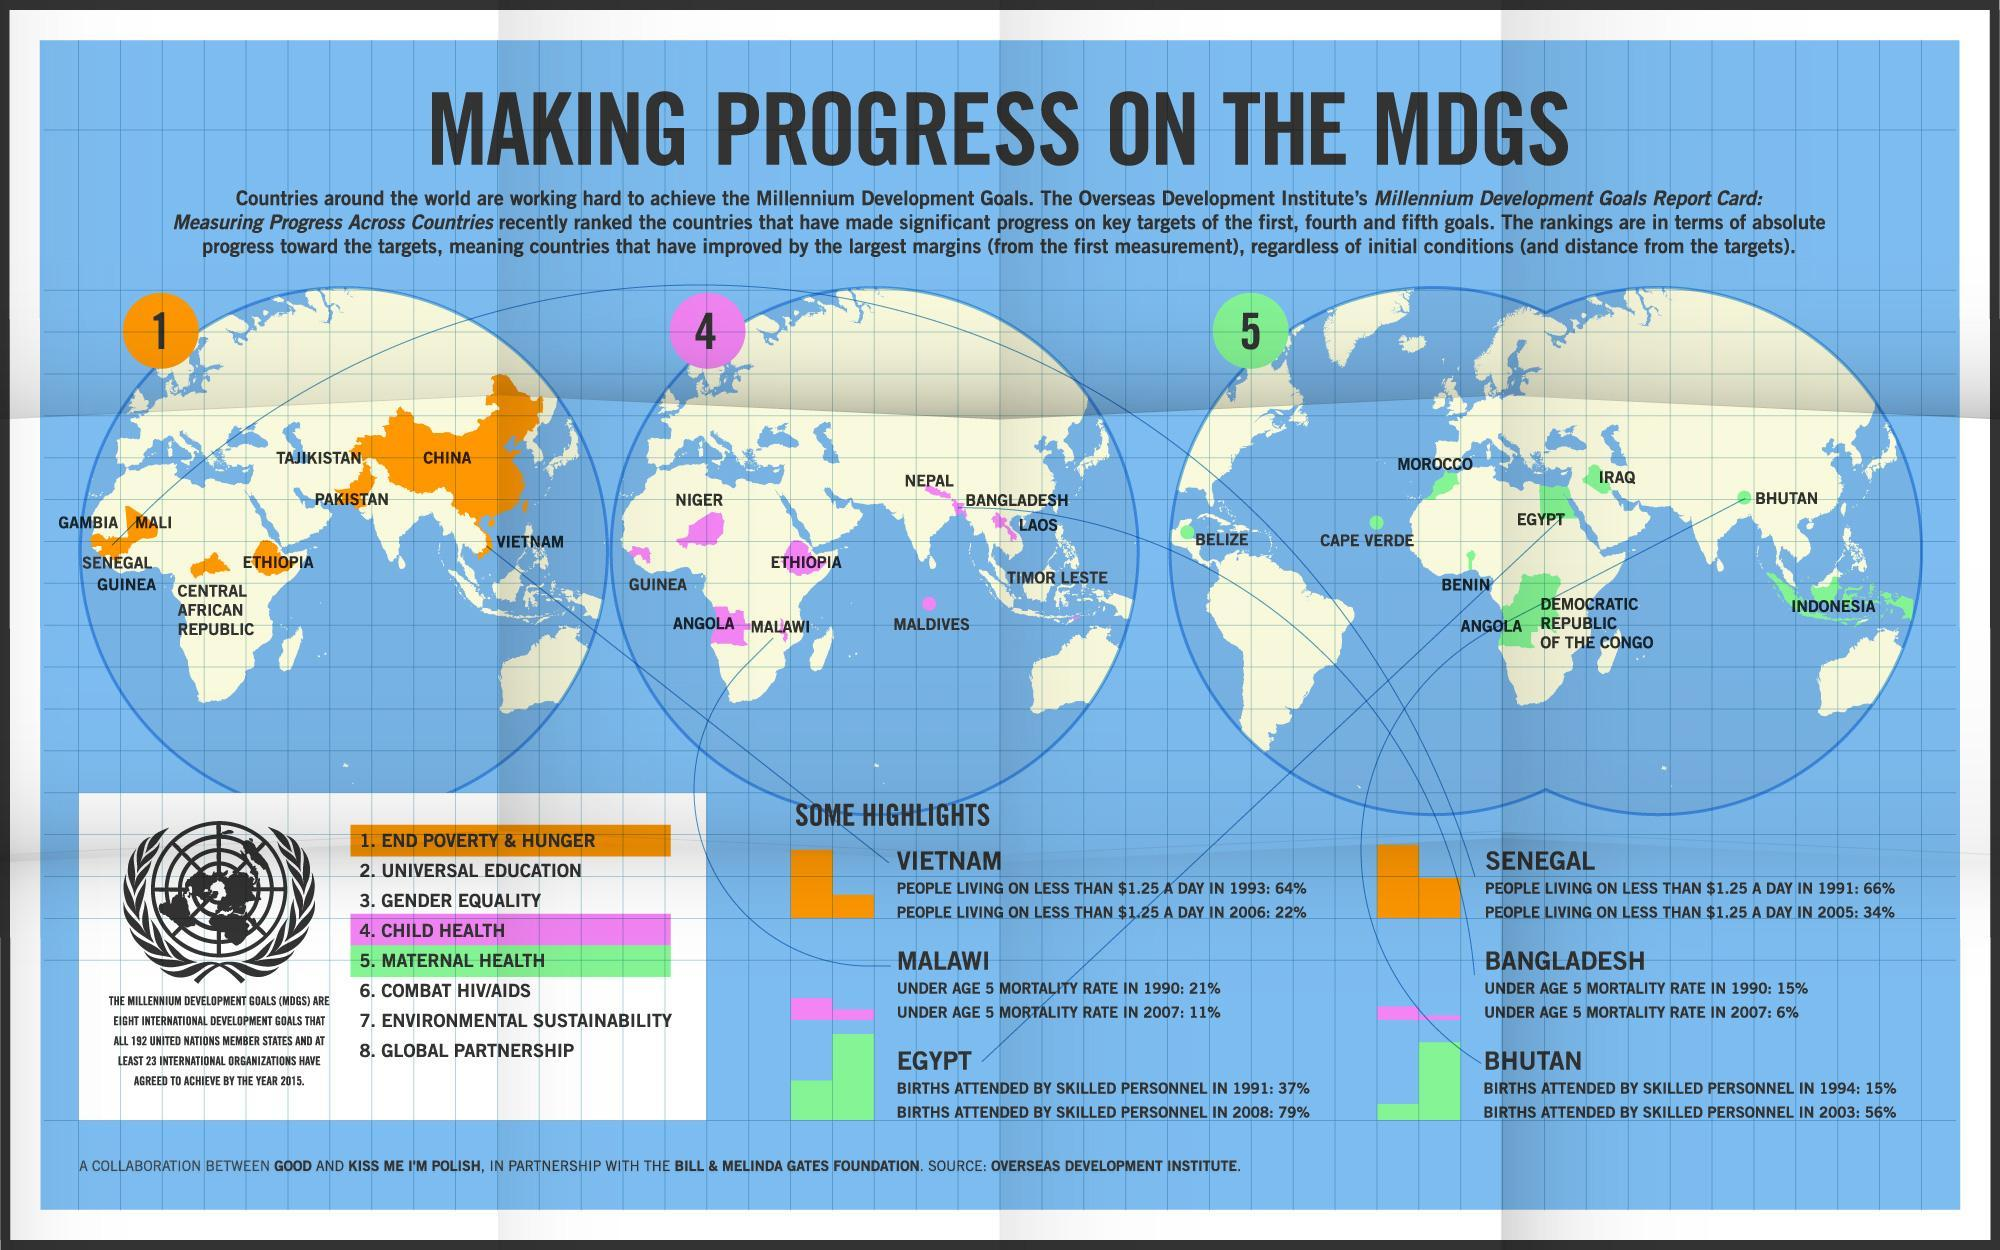In which MDGs, progress is to be achieved by Bangladesh by the year 2015?
Answer the question with a short phrase. CHILD HEALTH In which MDGs, progress is to be achieved by Vietnam by the year 2015? END POVERTY & HUNGER What percentage of births were attended by skilled personnels in Egypt in 1991? 37% What is the mortality rate of children under age 5 in Bangladesh in 1990? 15% In which MDGs, progress is to be achieved by Bhutan by the year 2015? MATERNAL HEALTH How many UN member states have agreed to achieve the MDGs by the year 2015? ALL 192 UNITED NATIONS MEMBER STATES What percentage of people are living in Senegal with less than $1.25 per day in 2005? 34% What is the mortality rate of children under age 5 in Malawi in 2007? 11% What is the primary goal of MDGS? END POVERTY & HUNGER What is the secondary goal of MDGS? UNIVERSAL EDUCATION 